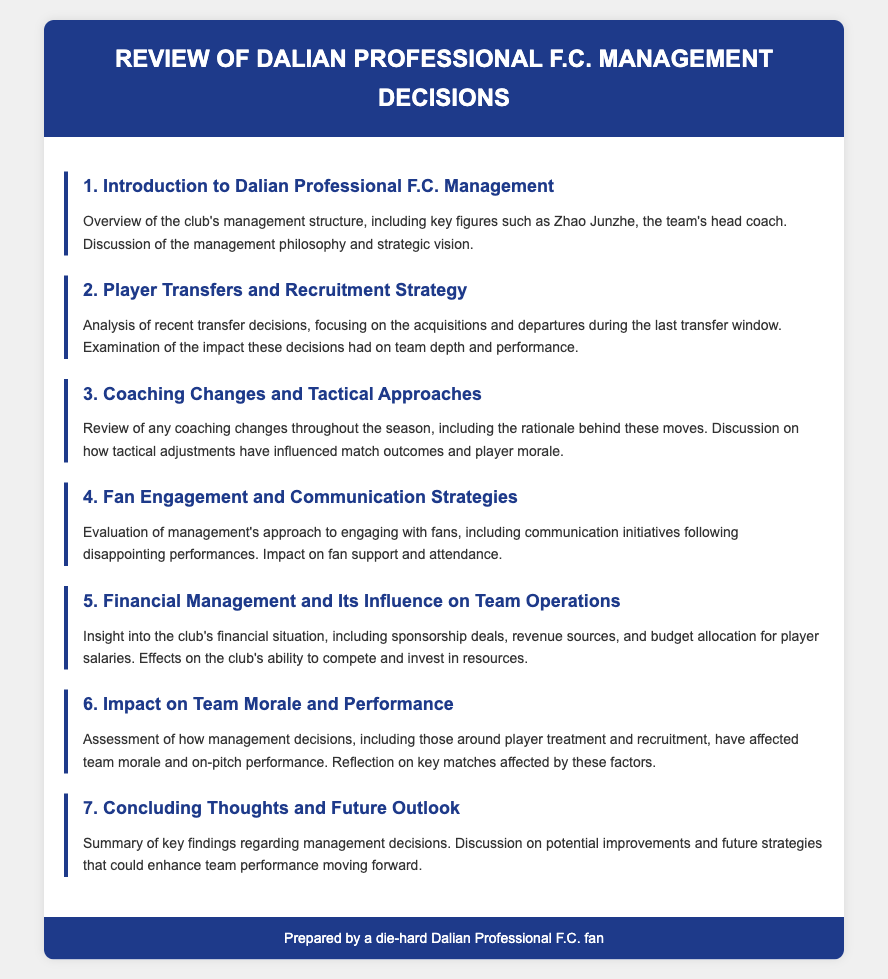What is the name of the head coach? The head coach of Dalian Professional F.C. is Zhao Junzhe.
Answer: Zhao Junzhe What section discusses player transfers? The discussion on player transfers is found in the second agenda item.
Answer: Player Transfers and Recruitment Strategy How many agenda items are there in total? The document includes seven distinct agenda items.
Answer: Seven What is evaluated in the fourth agenda item? The fourth agenda item evaluates management's approach to engaging with fans.
Answer: Fan Engagement and Communication Strategies Which aspect of management's financial situation is included? The document includes insights into sponsorship deals as part of the financial management evaluation.
Answer: Sponsorship deals What does the sixth agenda item assess? The sixth agenda item assesses how management decisions affected team morale and performance.
Answer: Team Morale and Performance What are the concluding thoughts summarized under? The concluding thoughts are summarized under the 'Concluding Thoughts and Future Outlook' agenda item.
Answer: Concluding Thoughts and Future Outlook What color is used for section headings? The color used for section headings is a shade of blue, specifically #1e3a8a.
Answer: Blue 